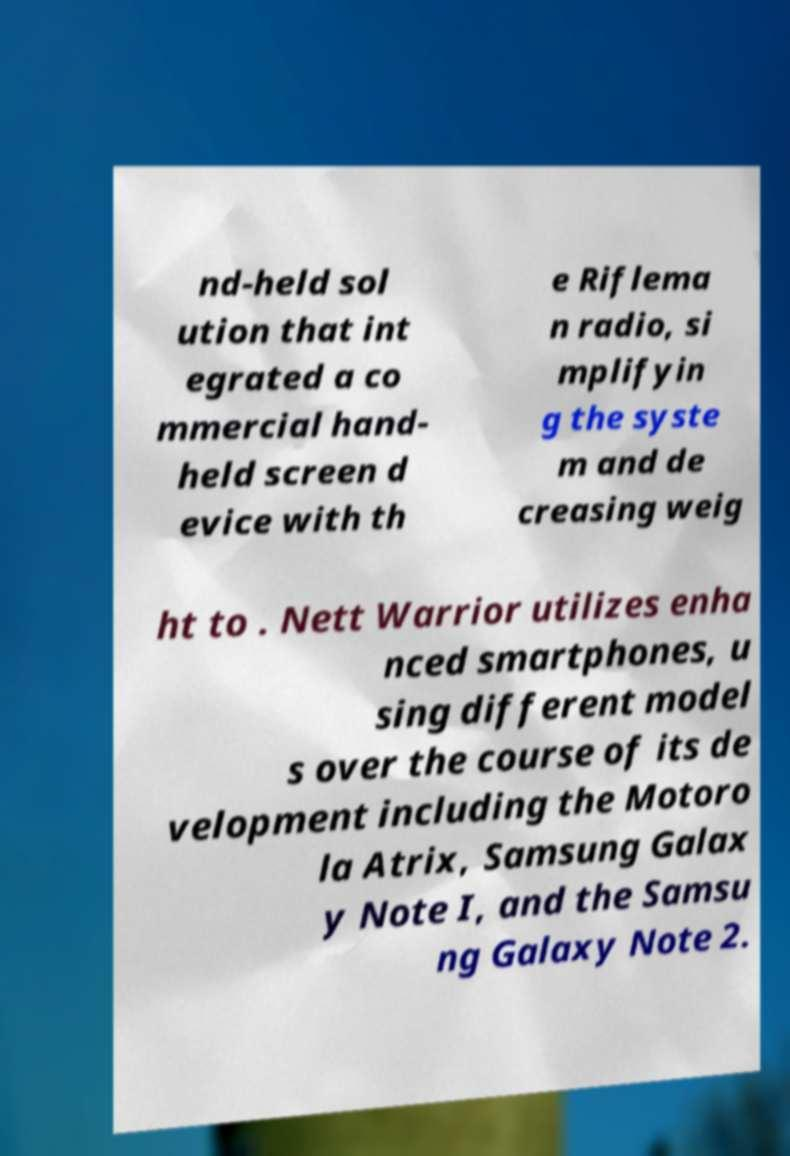Please identify and transcribe the text found in this image. nd-held sol ution that int egrated a co mmercial hand- held screen d evice with th e Riflema n radio, si mplifyin g the syste m and de creasing weig ht to . Nett Warrior utilizes enha nced smartphones, u sing different model s over the course of its de velopment including the Motoro la Atrix, Samsung Galax y Note I, and the Samsu ng Galaxy Note 2. 